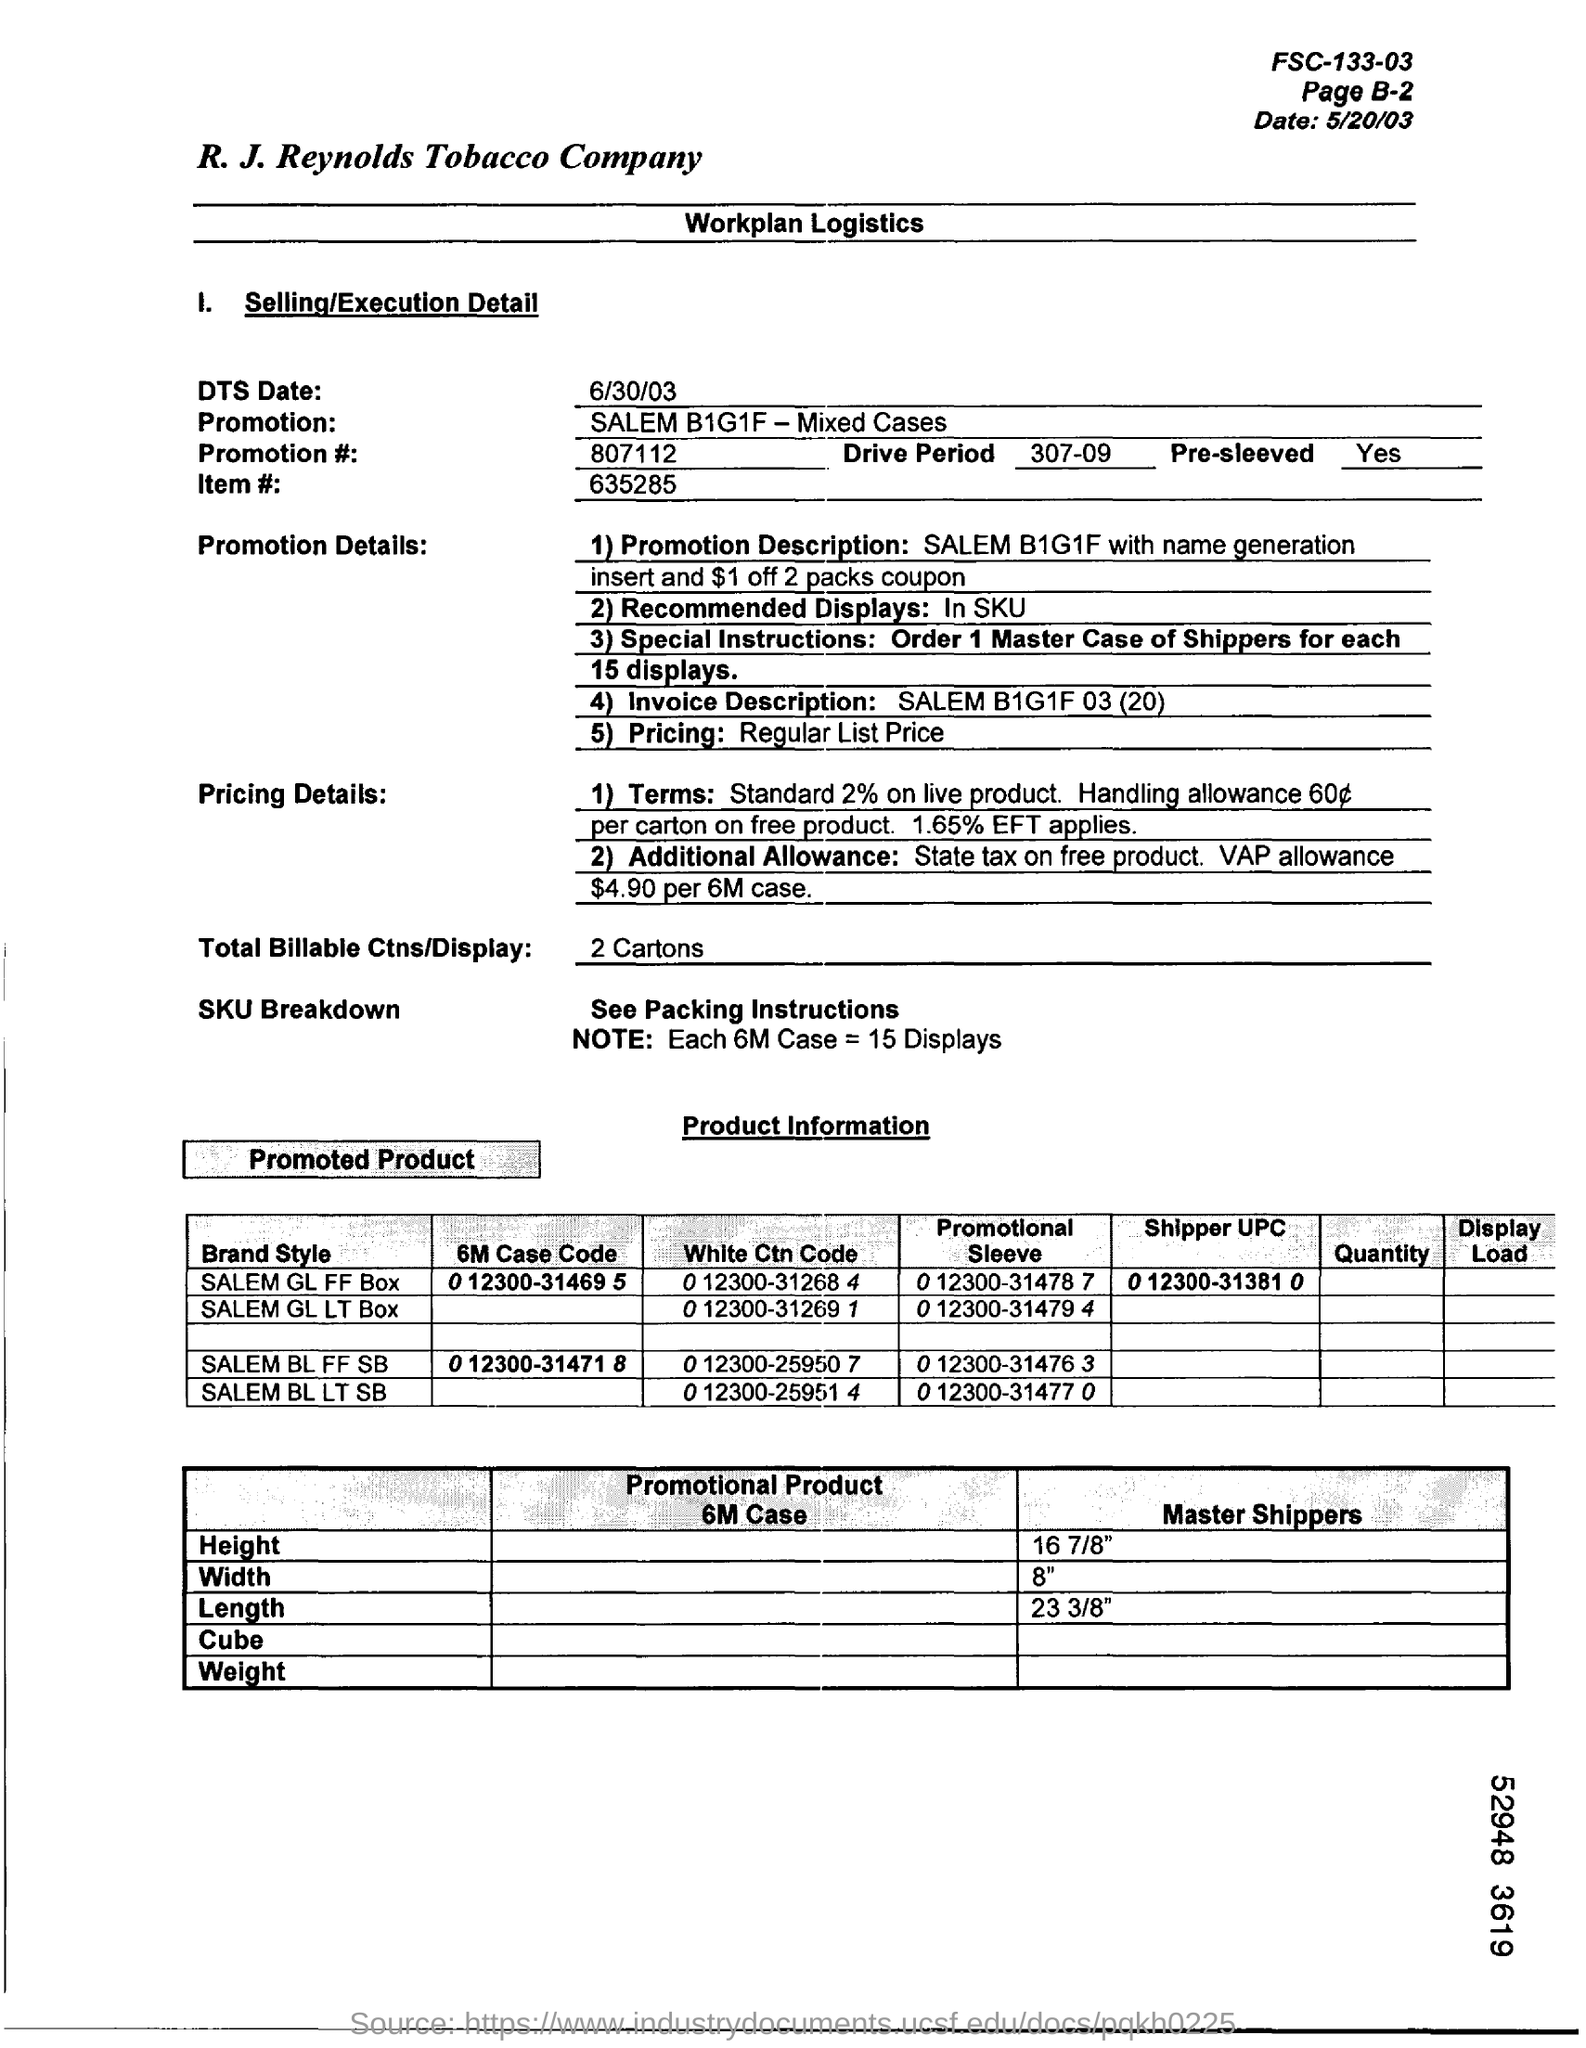What is the DTS Date?
Your answer should be very brief. 6/30/03. What is Total Billable Ctns/Display?
Keep it short and to the point. 2 Cartons. 